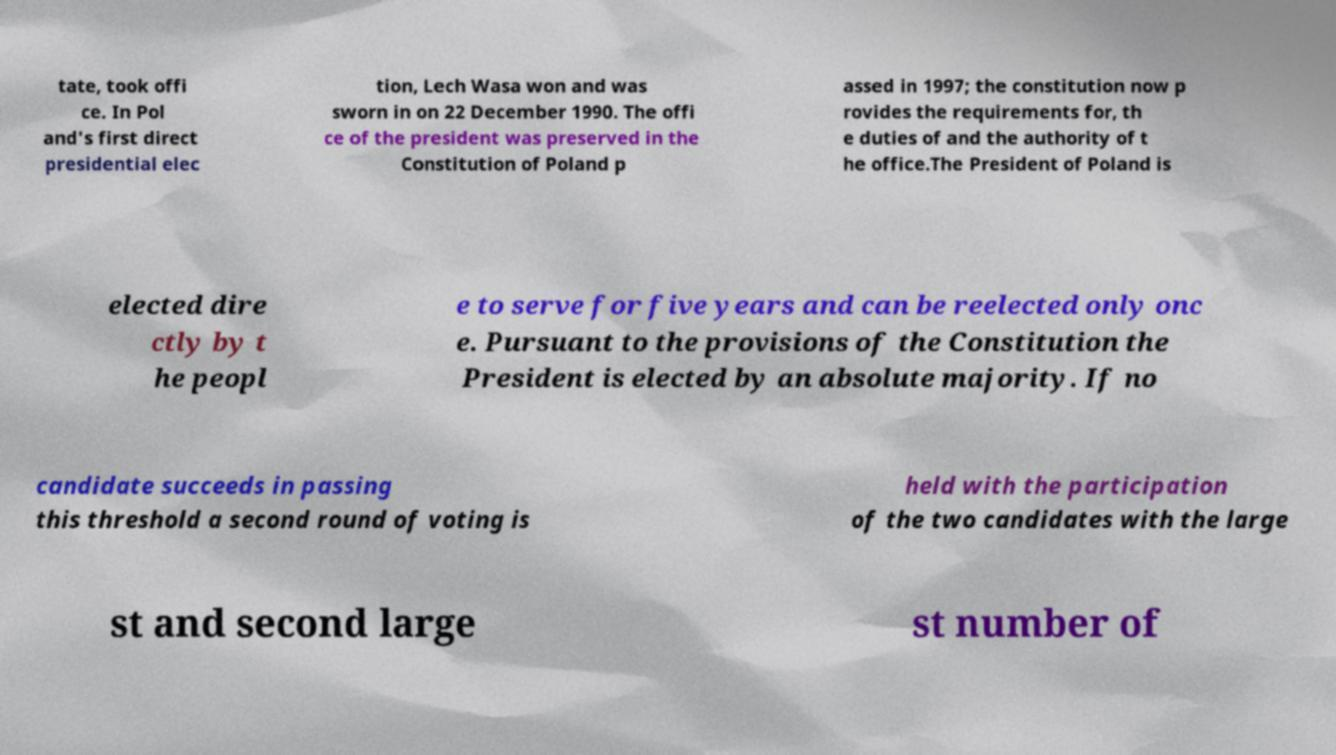Could you extract and type out the text from this image? tate, took offi ce. In Pol and's first direct presidential elec tion, Lech Wasa won and was sworn in on 22 December 1990. The offi ce of the president was preserved in the Constitution of Poland p assed in 1997; the constitution now p rovides the requirements for, th e duties of and the authority of t he office.The President of Poland is elected dire ctly by t he peopl e to serve for five years and can be reelected only onc e. Pursuant to the provisions of the Constitution the President is elected by an absolute majority. If no candidate succeeds in passing this threshold a second round of voting is held with the participation of the two candidates with the large st and second large st number of 